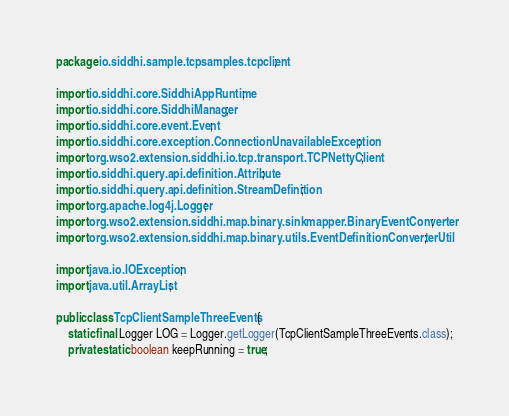<code> <loc_0><loc_0><loc_500><loc_500><_Java_>package io.siddhi.sample.tcpsamples.tcpclient;

import io.siddhi.core.SiddhiAppRuntime;
import io.siddhi.core.SiddhiManager;
import io.siddhi.core.event.Event;
import io.siddhi.core.exception.ConnectionUnavailableException;
import org.wso2.extension.siddhi.io.tcp.transport.TCPNettyClient;
import io.siddhi.query.api.definition.Attribute;
import io.siddhi.query.api.definition.StreamDefinition;
import org.apache.log4j.Logger;
import org.wso2.extension.siddhi.map.binary.sinkmapper.BinaryEventConverter;
import org.wso2.extension.siddhi.map.binary.utils.EventDefinitionConverterUtil;

import java.io.IOException;
import java.util.ArrayList;

public class TcpClientSampleThreeEvents {
    static final Logger LOG = Logger.getLogger(TcpClientSampleThreeEvents.class);
    private static boolean keepRunning = true;
</code> 